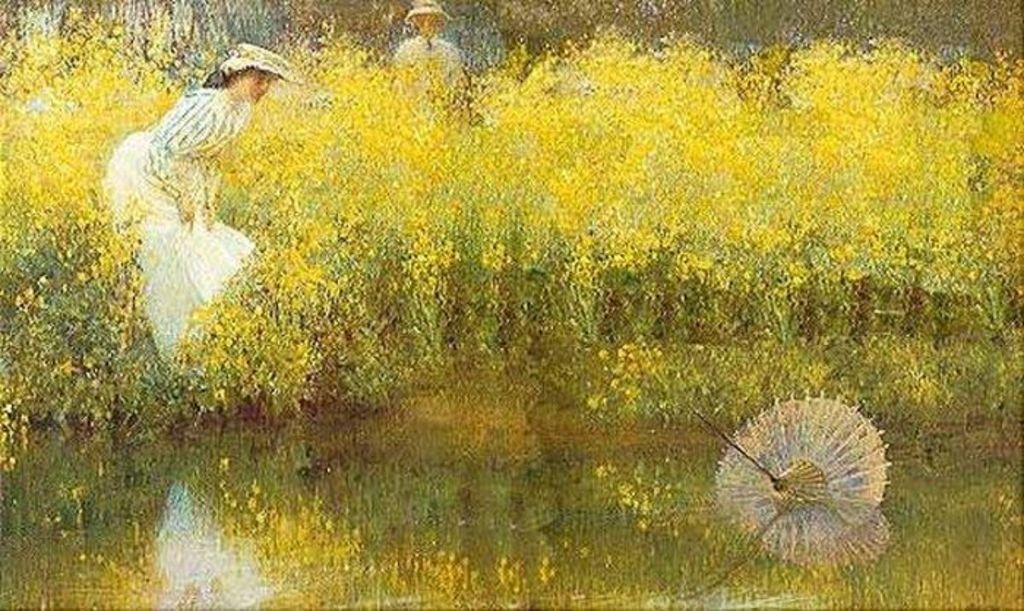Please provide a concise description of this image. In this picture painting of people, plants, flowers and an umbrella in the water. 